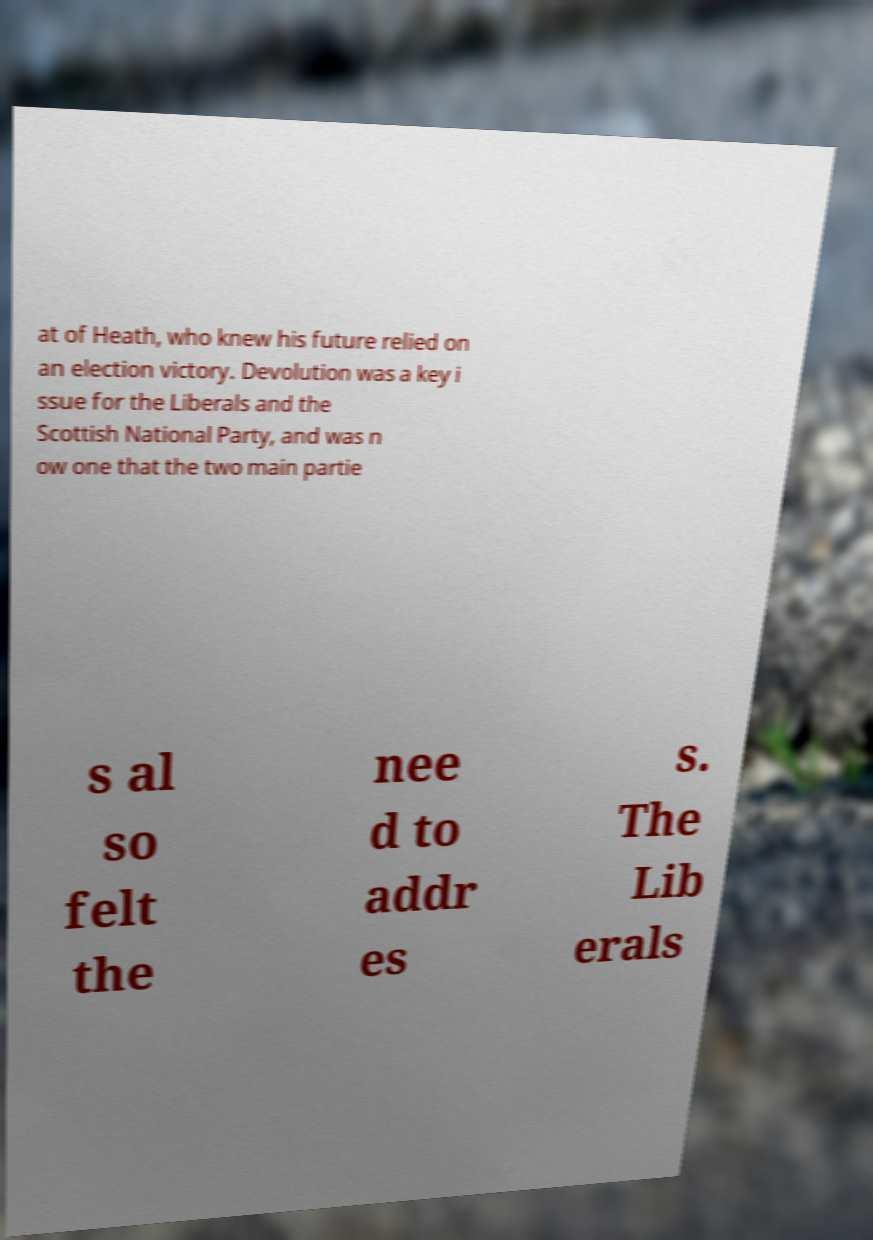There's text embedded in this image that I need extracted. Can you transcribe it verbatim? at of Heath, who knew his future relied on an election victory. Devolution was a key i ssue for the Liberals and the Scottish National Party, and was n ow one that the two main partie s al so felt the nee d to addr es s. The Lib erals 